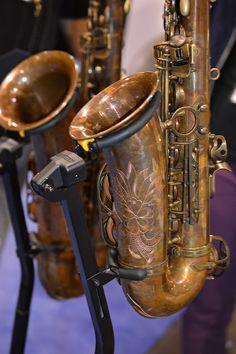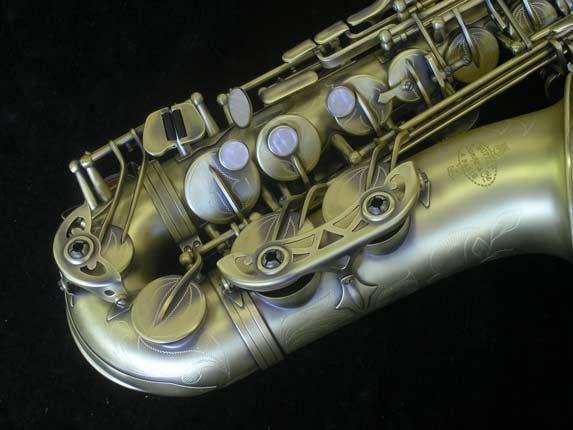The first image is the image on the left, the second image is the image on the right. Considering the images on both sides, is "Both saxophones are positioned upright." valid? Answer yes or no. No. The first image is the image on the left, the second image is the image on the right. For the images displayed, is the sentence "One image shows a single saxophone displayed nearly vertically, and one shows a saxophone displayed diagonally at about a 45-degree angle." factually correct? Answer yes or no. No. The first image is the image on the left, the second image is the image on the right. Given the left and right images, does the statement "Each image shows a single saxophone displayed so it is nearly vertical." hold true? Answer yes or no. No. The first image is the image on the left, the second image is the image on the right. Considering the images on both sides, is "All instruments on the left hand image are displayed vertically, while they are displayed horizontally or diagonally on the right hand images." valid? Answer yes or no. Yes. 